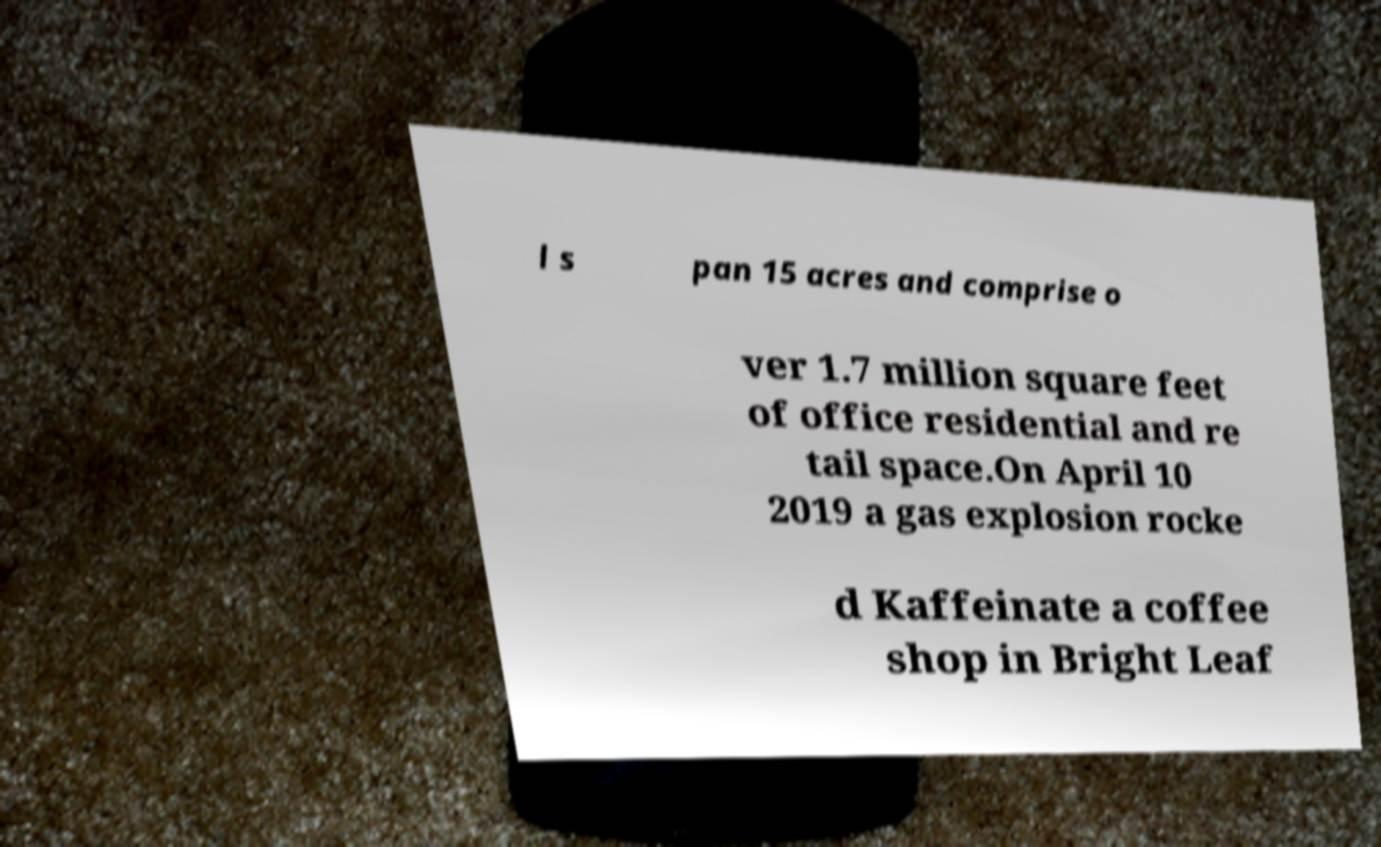For documentation purposes, I need the text within this image transcribed. Could you provide that? l s pan 15 acres and comprise o ver 1.7 million square feet of office residential and re tail space.On April 10 2019 a gas explosion rocke d Kaffeinate a coffee shop in Bright Leaf 